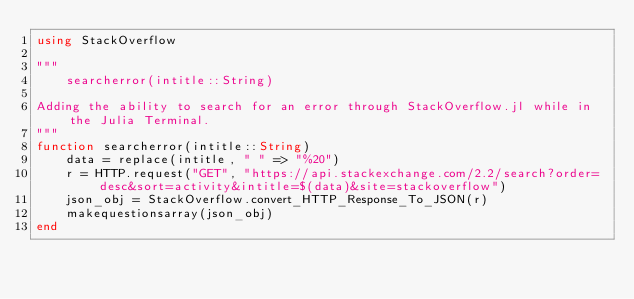<code> <loc_0><loc_0><loc_500><loc_500><_Julia_>using StackOverflow

"""
    searcherror(intitle::String)

Adding the ability to search for an error through StackOverflow.jl while in the Julia Terminal.
"""
function searcherror(intitle::String)
    data = replace(intitle, " " => "%20")
    r = HTTP.request("GET", "https://api.stackexchange.com/2.2/search?order=desc&sort=activity&intitle=$(data)&site=stackoverflow")
    json_obj = StackOverflow.convert_HTTP_Response_To_JSON(r)
    makequestionsarray(json_obj)
end
</code> 